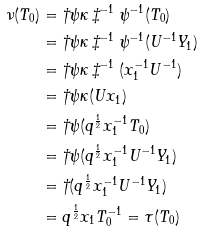Convert formula to latex. <formula><loc_0><loc_0><loc_500><loc_500>\nu ( T _ { 0 } ) & = \dagger \psi \kappa \ddagger ^ { - 1 } \psi ^ { - 1 } ( T _ { 0 } ) \\ & = \dagger \psi \kappa \ddagger ^ { - 1 } \psi ^ { - 1 } ( U ^ { - 1 } Y _ { 1 } ) \\ & = \dagger \psi \kappa \ddagger ^ { - 1 } ( x _ { 1 } ^ { - 1 } U ^ { - 1 } ) \\ & = \dagger \psi \kappa ( U x _ { 1 } ) \\ & = \dagger \psi ( q ^ { \frac { 1 } { 2 } } x _ { 1 } ^ { - 1 } T _ { 0 } ) \\ & = \dagger \psi ( q ^ { \frac { 1 } { 2 } } x _ { 1 } ^ { - 1 } U ^ { - 1 } Y _ { 1 } ) \\ & = \dagger ( q ^ { \frac { 1 } { 2 } } x _ { 1 } ^ { - 1 } U ^ { - 1 } Y _ { 1 } ) \\ & = q ^ { \frac { 1 } { 2 } } x _ { 1 } T _ { 0 } ^ { - 1 } = \tau ( T _ { 0 } )</formula> 